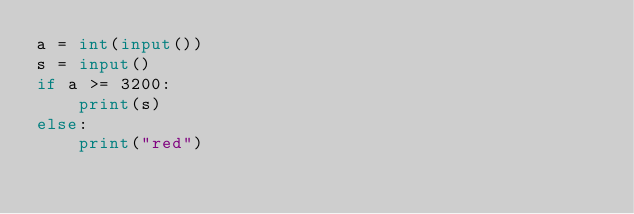<code> <loc_0><loc_0><loc_500><loc_500><_Python_>a = int(input())
s = input()
if a >= 3200:
	print(s)
else:
	print("red")</code> 